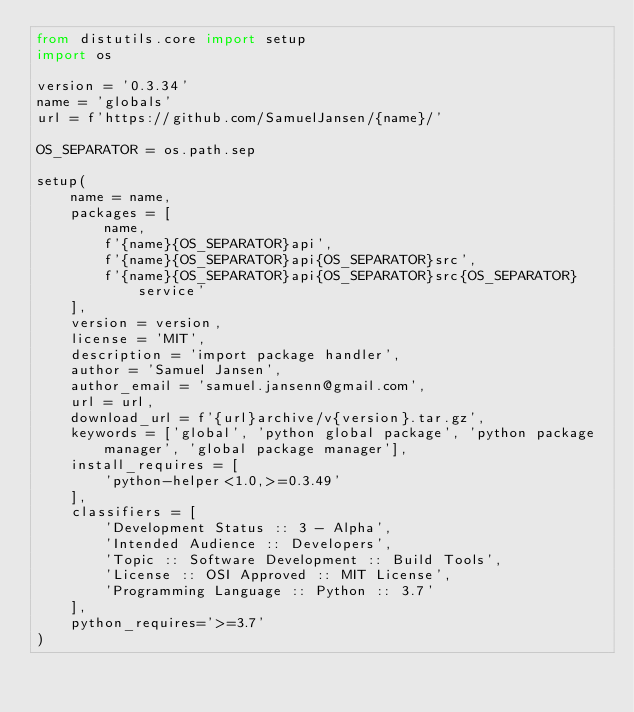<code> <loc_0><loc_0><loc_500><loc_500><_Python_>from distutils.core import setup
import os

version = '0.3.34'
name = 'globals'
url = f'https://github.com/SamuelJansen/{name}/'

OS_SEPARATOR = os.path.sep

setup(
    name = name,
    packages = [
        name,
        f'{name}{OS_SEPARATOR}api',
        f'{name}{OS_SEPARATOR}api{OS_SEPARATOR}src',
        f'{name}{OS_SEPARATOR}api{OS_SEPARATOR}src{OS_SEPARATOR}service'
    ],
    version = version,
    license = 'MIT',
    description = 'import package handler',
    author = 'Samuel Jansen',
    author_email = 'samuel.jansenn@gmail.com',
    url = url,
    download_url = f'{url}archive/v{version}.tar.gz',
    keywords = ['global', 'python global package', 'python package manager', 'global package manager'],
    install_requires = [
        'python-helper<1.0,>=0.3.49'
    ],
    classifiers = [
        'Development Status :: 3 - Alpha',
        'Intended Audience :: Developers',
        'Topic :: Software Development :: Build Tools',
        'License :: OSI Approved :: MIT License',
        'Programming Language :: Python :: 3.7'
    ],
    python_requires='>=3.7'
)
</code> 